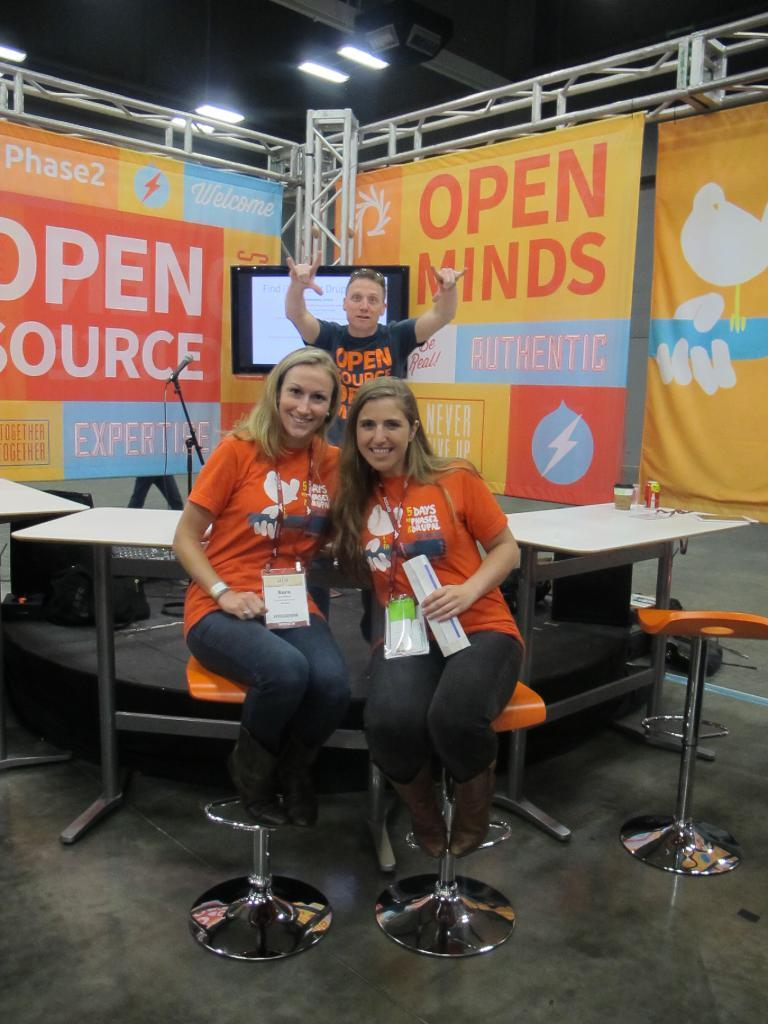How many people are present in the image? There are three people in the image. What can be seen in the background of the image? There are tables, a screen, a banner, and lights in the background of the image. What type of store can be seen in the aftermath of the image? There is no store present in the image, nor is there any indication of an aftermath. 